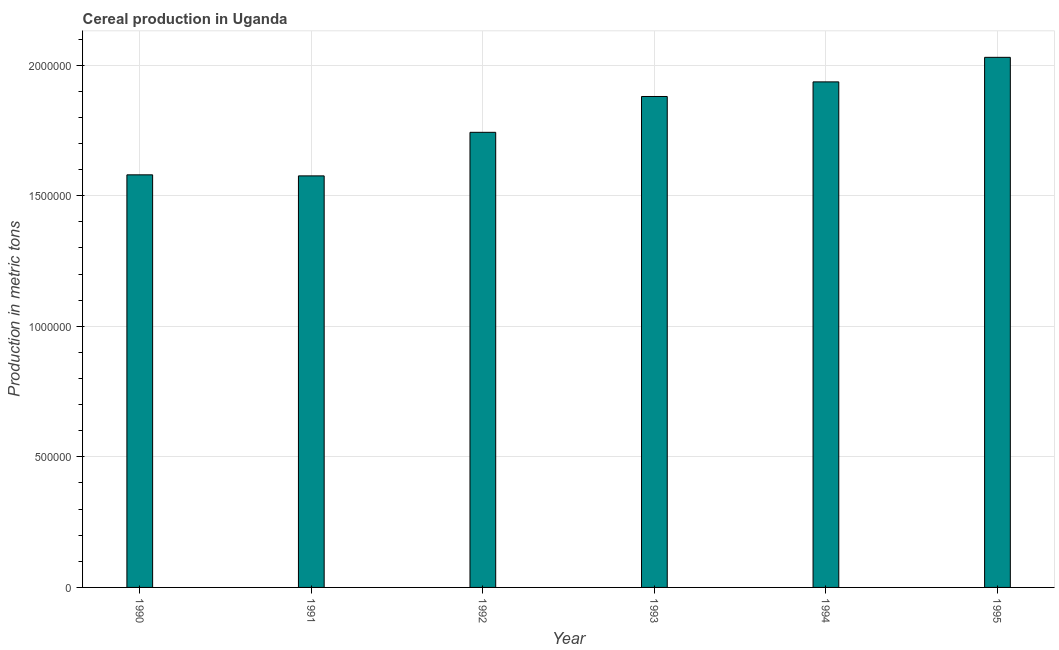Does the graph contain any zero values?
Give a very brief answer. No. What is the title of the graph?
Provide a succinct answer. Cereal production in Uganda. What is the label or title of the Y-axis?
Offer a terse response. Production in metric tons. What is the cereal production in 1995?
Make the answer very short. 2.03e+06. Across all years, what is the maximum cereal production?
Ensure brevity in your answer.  2.03e+06. Across all years, what is the minimum cereal production?
Provide a short and direct response. 1.58e+06. What is the sum of the cereal production?
Your response must be concise. 1.07e+07. What is the difference between the cereal production in 1992 and 1994?
Your response must be concise. -1.93e+05. What is the average cereal production per year?
Keep it short and to the point. 1.79e+06. What is the median cereal production?
Your answer should be compact. 1.81e+06. In how many years, is the cereal production greater than 800000 metric tons?
Offer a very short reply. 6. What is the difference between the highest and the second highest cereal production?
Your answer should be very brief. 9.40e+04. What is the difference between the highest and the lowest cereal production?
Offer a very short reply. 4.54e+05. In how many years, is the cereal production greater than the average cereal production taken over all years?
Your response must be concise. 3. How many bars are there?
Give a very brief answer. 6. Are all the bars in the graph horizontal?
Provide a succinct answer. No. What is the difference between two consecutive major ticks on the Y-axis?
Your response must be concise. 5.00e+05. What is the Production in metric tons in 1990?
Give a very brief answer. 1.58e+06. What is the Production in metric tons of 1991?
Make the answer very short. 1.58e+06. What is the Production in metric tons in 1992?
Keep it short and to the point. 1.74e+06. What is the Production in metric tons of 1993?
Offer a terse response. 1.88e+06. What is the Production in metric tons of 1994?
Ensure brevity in your answer.  1.94e+06. What is the Production in metric tons in 1995?
Make the answer very short. 2.03e+06. What is the difference between the Production in metric tons in 1990 and 1991?
Offer a very short reply. 4000. What is the difference between the Production in metric tons in 1990 and 1992?
Your answer should be compact. -1.63e+05. What is the difference between the Production in metric tons in 1990 and 1994?
Give a very brief answer. -3.56e+05. What is the difference between the Production in metric tons in 1990 and 1995?
Provide a short and direct response. -4.50e+05. What is the difference between the Production in metric tons in 1991 and 1992?
Make the answer very short. -1.67e+05. What is the difference between the Production in metric tons in 1991 and 1993?
Offer a very short reply. -3.04e+05. What is the difference between the Production in metric tons in 1991 and 1994?
Your answer should be compact. -3.60e+05. What is the difference between the Production in metric tons in 1991 and 1995?
Make the answer very short. -4.54e+05. What is the difference between the Production in metric tons in 1992 and 1993?
Ensure brevity in your answer.  -1.37e+05. What is the difference between the Production in metric tons in 1992 and 1994?
Ensure brevity in your answer.  -1.93e+05. What is the difference between the Production in metric tons in 1992 and 1995?
Your answer should be compact. -2.87e+05. What is the difference between the Production in metric tons in 1993 and 1994?
Offer a terse response. -5.60e+04. What is the difference between the Production in metric tons in 1993 and 1995?
Offer a terse response. -1.50e+05. What is the difference between the Production in metric tons in 1994 and 1995?
Ensure brevity in your answer.  -9.40e+04. What is the ratio of the Production in metric tons in 1990 to that in 1992?
Provide a succinct answer. 0.91. What is the ratio of the Production in metric tons in 1990 to that in 1993?
Make the answer very short. 0.84. What is the ratio of the Production in metric tons in 1990 to that in 1994?
Offer a terse response. 0.82. What is the ratio of the Production in metric tons in 1990 to that in 1995?
Offer a terse response. 0.78. What is the ratio of the Production in metric tons in 1991 to that in 1992?
Provide a succinct answer. 0.9. What is the ratio of the Production in metric tons in 1991 to that in 1993?
Ensure brevity in your answer.  0.84. What is the ratio of the Production in metric tons in 1991 to that in 1994?
Keep it short and to the point. 0.81. What is the ratio of the Production in metric tons in 1991 to that in 1995?
Offer a very short reply. 0.78. What is the ratio of the Production in metric tons in 1992 to that in 1993?
Make the answer very short. 0.93. What is the ratio of the Production in metric tons in 1992 to that in 1995?
Your answer should be compact. 0.86. What is the ratio of the Production in metric tons in 1993 to that in 1995?
Make the answer very short. 0.93. What is the ratio of the Production in metric tons in 1994 to that in 1995?
Offer a terse response. 0.95. 